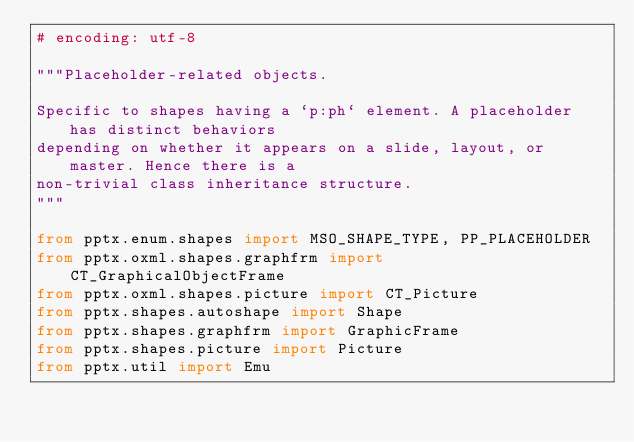Convert code to text. <code><loc_0><loc_0><loc_500><loc_500><_Python_># encoding: utf-8

"""Placeholder-related objects.

Specific to shapes having a `p:ph` element. A placeholder has distinct behaviors
depending on whether it appears on a slide, layout, or master. Hence there is a
non-trivial class inheritance structure.
"""

from pptx.enum.shapes import MSO_SHAPE_TYPE, PP_PLACEHOLDER
from pptx.oxml.shapes.graphfrm import CT_GraphicalObjectFrame
from pptx.oxml.shapes.picture import CT_Picture
from pptx.shapes.autoshape import Shape
from pptx.shapes.graphfrm import GraphicFrame
from pptx.shapes.picture import Picture
from pptx.util import Emu

</code> 